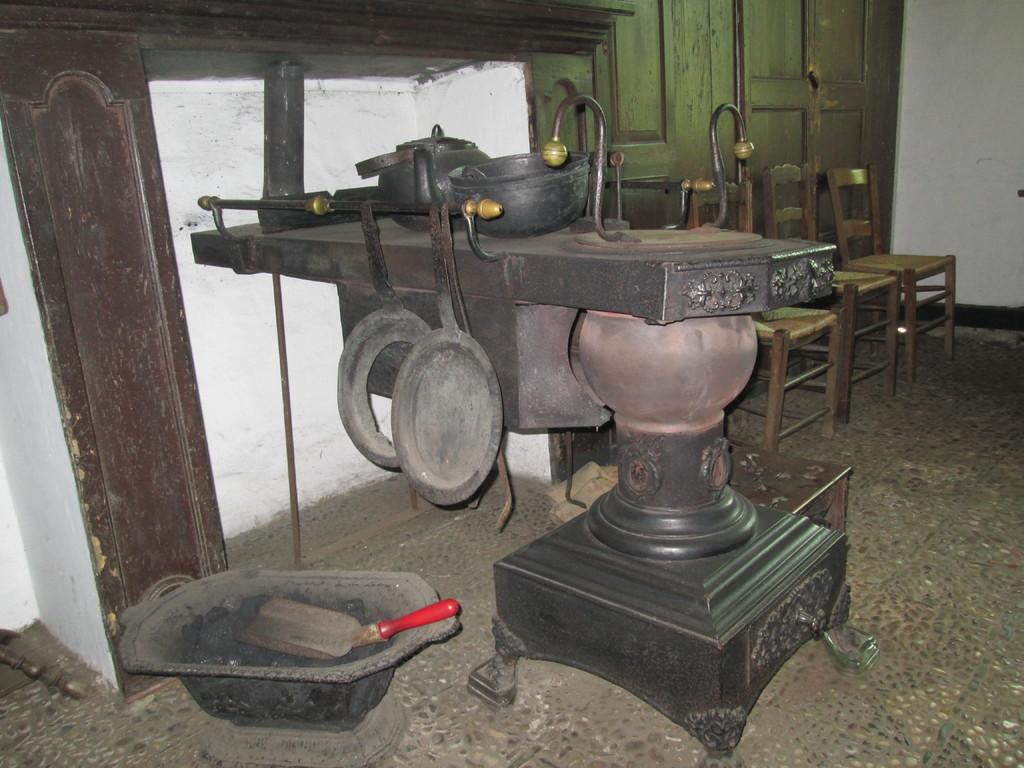What type of machine is visible in the image? The machine appears to be a forging machine. What can be seen in the background of the image? There are chairs and a door in the background of the image. What is visible at the bottom of the image? There is a floor visible at the bottom of the image. What is on the left side of the image? There is a wall on the left side of the image. What type of twig is growing on the machine in the image? There is no twig present in the image, and the machine is not a plant or tree that could support growth. 